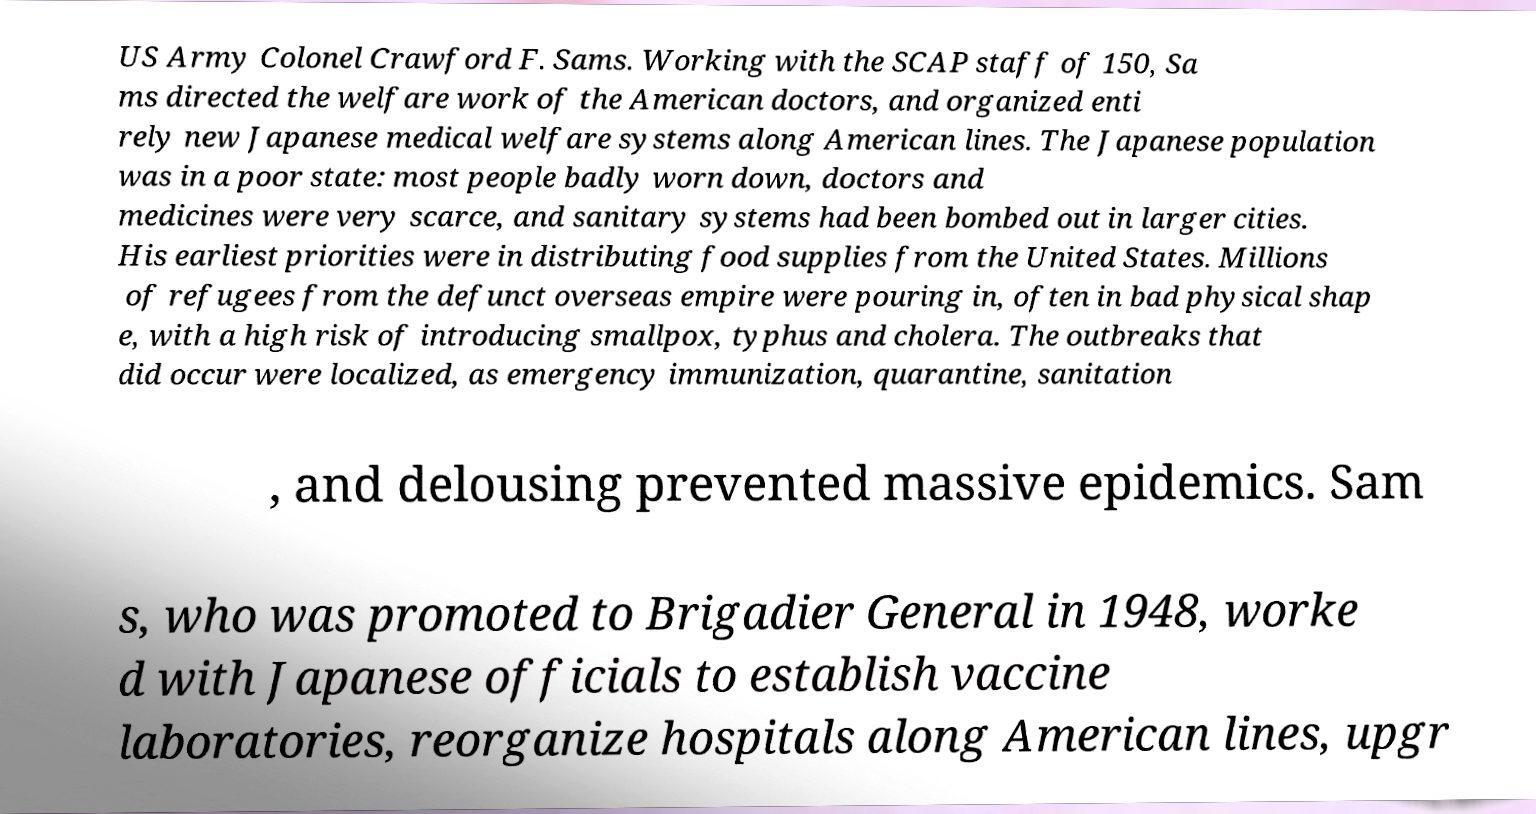Please read and relay the text visible in this image. What does it say? US Army Colonel Crawford F. Sams. Working with the SCAP staff of 150, Sa ms directed the welfare work of the American doctors, and organized enti rely new Japanese medical welfare systems along American lines. The Japanese population was in a poor state: most people badly worn down, doctors and medicines were very scarce, and sanitary systems had been bombed out in larger cities. His earliest priorities were in distributing food supplies from the United States. Millions of refugees from the defunct overseas empire were pouring in, often in bad physical shap e, with a high risk of introducing smallpox, typhus and cholera. The outbreaks that did occur were localized, as emergency immunization, quarantine, sanitation , and delousing prevented massive epidemics. Sam s, who was promoted to Brigadier General in 1948, worke d with Japanese officials to establish vaccine laboratories, reorganize hospitals along American lines, upgr 